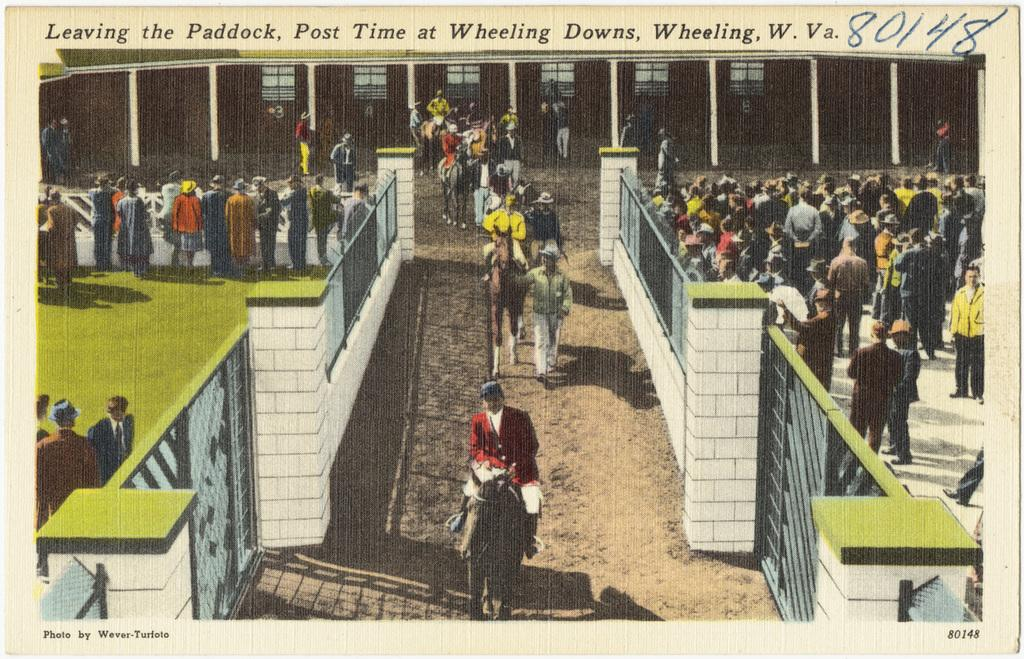<image>
Present a compact description of the photo's key features. Competition is going to start soon and the horses are leaving the paddock. 